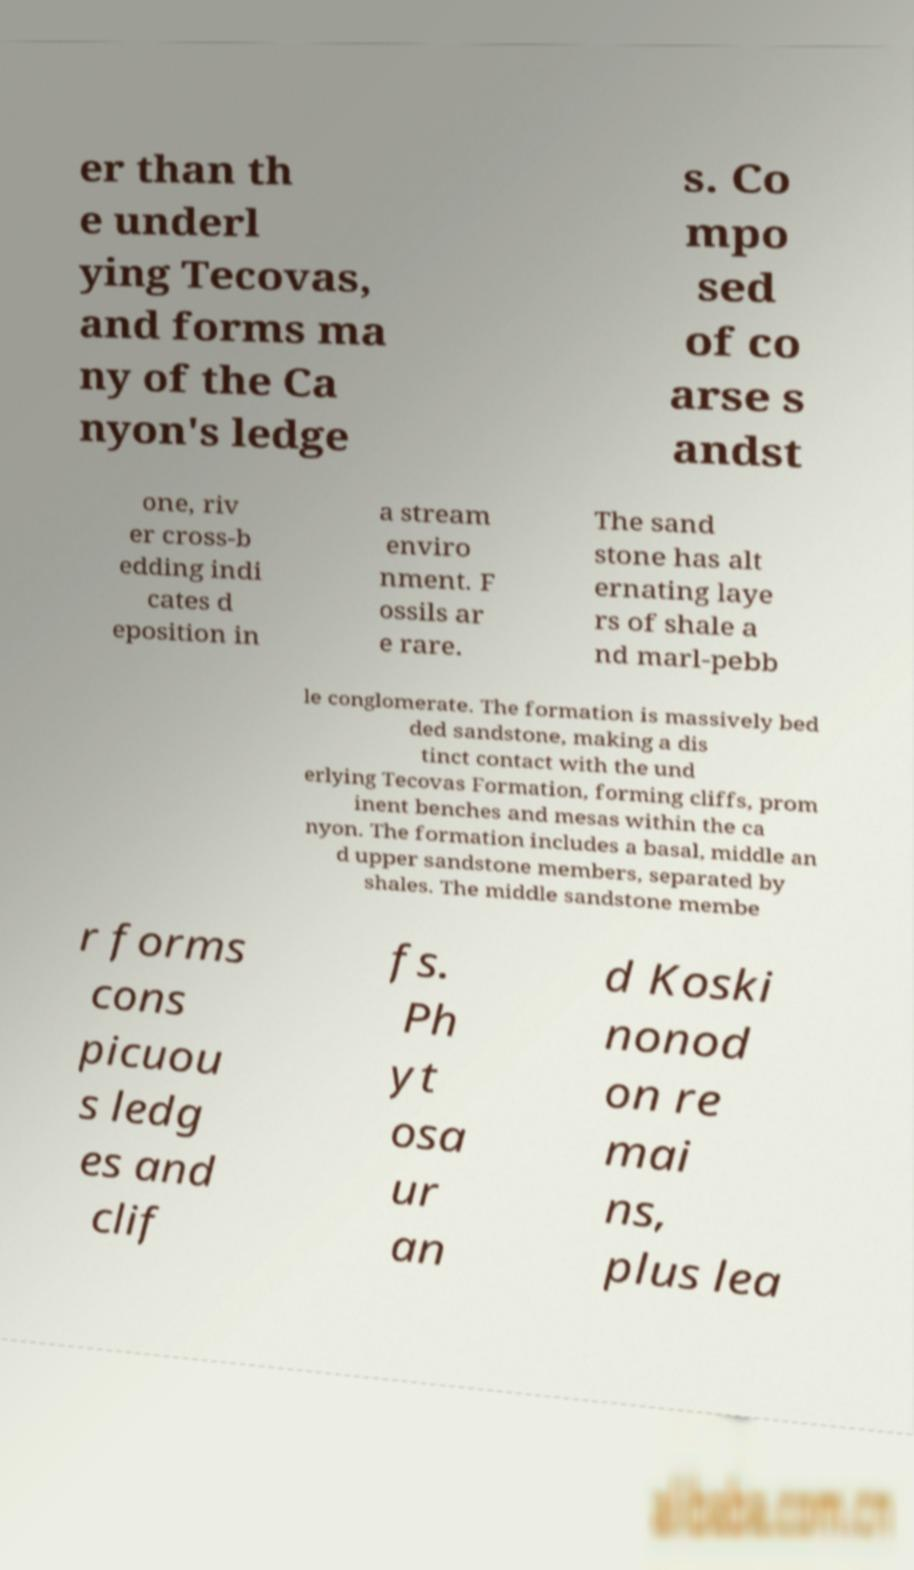Can you read and provide the text displayed in the image?This photo seems to have some interesting text. Can you extract and type it out for me? er than th e underl ying Tecovas, and forms ma ny of the Ca nyon's ledge s. Co mpo sed of co arse s andst one, riv er cross-b edding indi cates d eposition in a stream enviro nment. F ossils ar e rare. The sand stone has alt ernating laye rs of shale a nd marl-pebb le conglomerate. The formation is massively bed ded sandstone, making a dis tinct contact with the und erlying Tecovas Formation, forming cliffs, prom inent benches and mesas within the ca nyon. The formation includes a basal, middle an d upper sandstone members, separated by shales. The middle sandstone membe r forms cons picuou s ledg es and clif fs. Ph yt osa ur an d Koski nonod on re mai ns, plus lea 